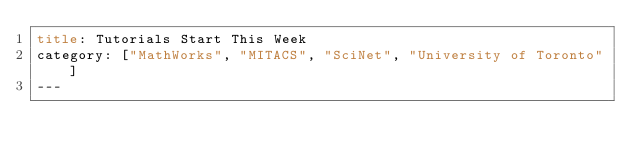<code> <loc_0><loc_0><loc_500><loc_500><_HTML_>title: Tutorials Start This Week
category: ["MathWorks", "MITACS", "SciNet", "University of Toronto"]
---</code> 